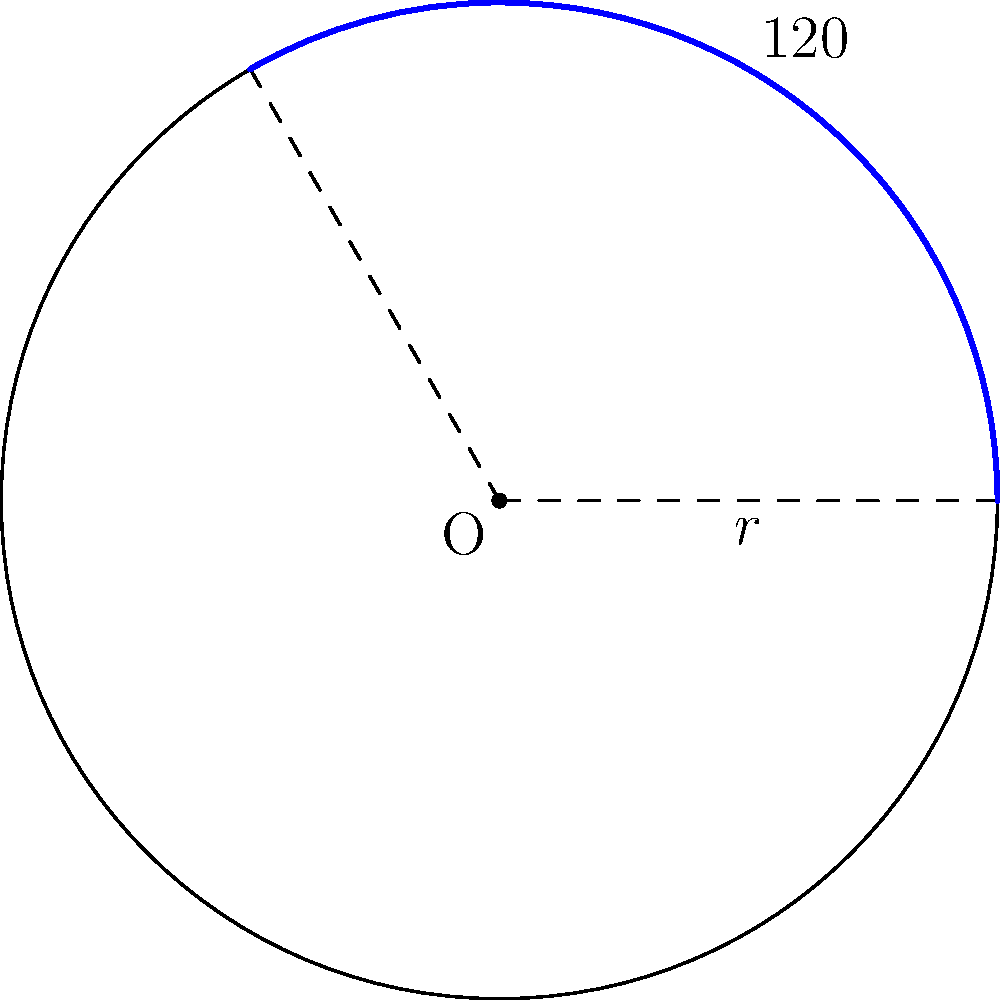For an upcoming sci-fi film, you need to create a curved set piece that represents a portion of a spaceship's hull. The set piece is an arc of a circle with radius 15 meters, and it spans an angle of 120°. Calculate the length of this arc to ensure accurate construction of the set piece. To find the length of an arc, we can use the formula:

$$s = r\theta$$

Where:
$s$ is the arc length
$r$ is the radius of the circle
$\theta$ is the central angle in radians

Steps to solve:

1. We have the radius $r = 15$ meters.
2. The angle is given as 120°, but we need to convert it to radians:
   $$\theta = 120° \times \frac{\pi}{180°} = \frac{2\pi}{3} \approx 2.0944 \text{ radians}$$
3. Now we can substitute these values into our formula:
   $$s = r\theta = 15 \times \frac{2\pi}{3}$$
4. Simplify:
   $$s = 10\pi \approx 31.4159 \text{ meters}$$

Therefore, the length of the arc for the set piece is approximately 31.4159 meters.
Answer: $10\pi$ meters or approximately 31.4159 meters 